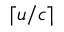Convert formula to latex. <formula><loc_0><loc_0><loc_500><loc_500>\lceil u / c \rceil</formula> 